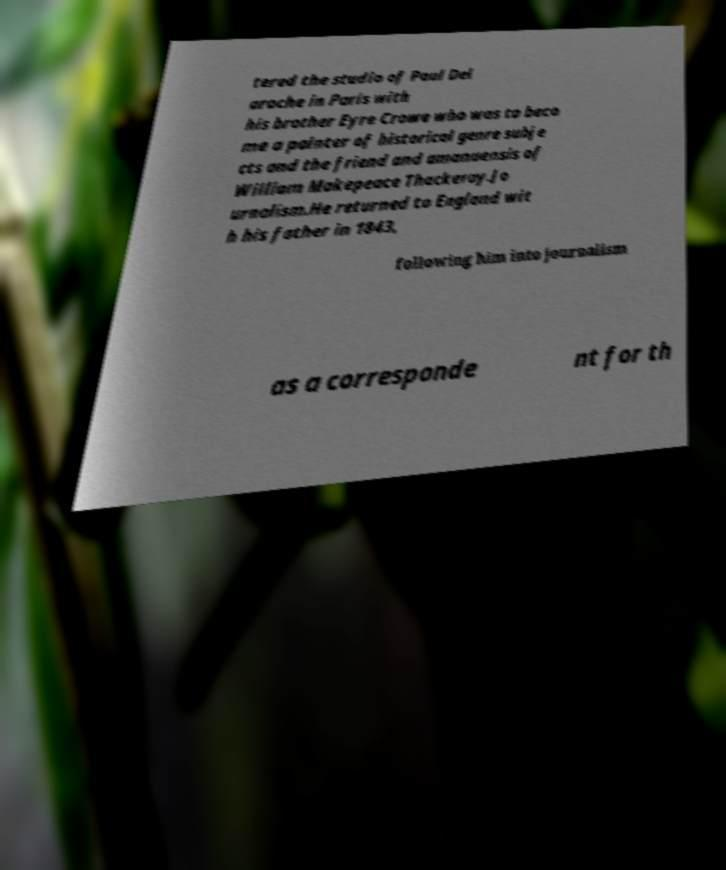I need the written content from this picture converted into text. Can you do that? tered the studio of Paul Del aroche in Paris with his brother Eyre Crowe who was to beco me a painter of historical genre subje cts and the friend and amanuensis of William Makepeace Thackeray.Jo urnalism.He returned to England wit h his father in 1843, following him into journalism as a corresponde nt for th 